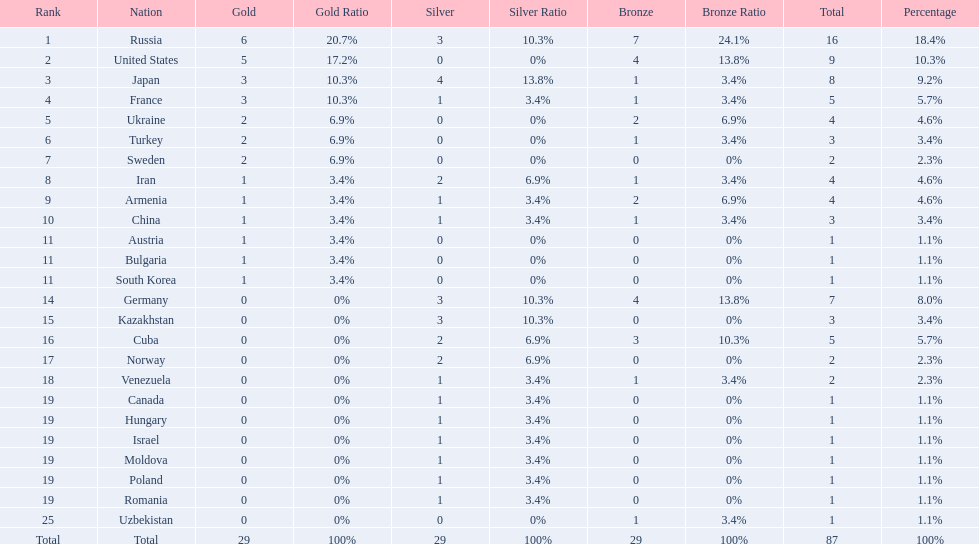Which nations only won less then 5 medals? Ukraine, Turkey, Sweden, Iran, Armenia, China, Austria, Bulgaria, South Korea, Germany, Kazakhstan, Norway, Venezuela, Canada, Hungary, Israel, Moldova, Poland, Romania, Uzbekistan. Which of these were not asian nations? Ukraine, Turkey, Sweden, Iran, Armenia, Austria, Bulgaria, Germany, Kazakhstan, Norway, Venezuela, Canada, Hungary, Israel, Moldova, Poland, Romania, Uzbekistan. Which of those did not win any silver medals? Ukraine, Turkey, Sweden, Austria, Bulgaria, Uzbekistan. Which ones of these had only one medal total? Austria, Bulgaria, Uzbekistan. Which of those would be listed first alphabetically? Austria. 